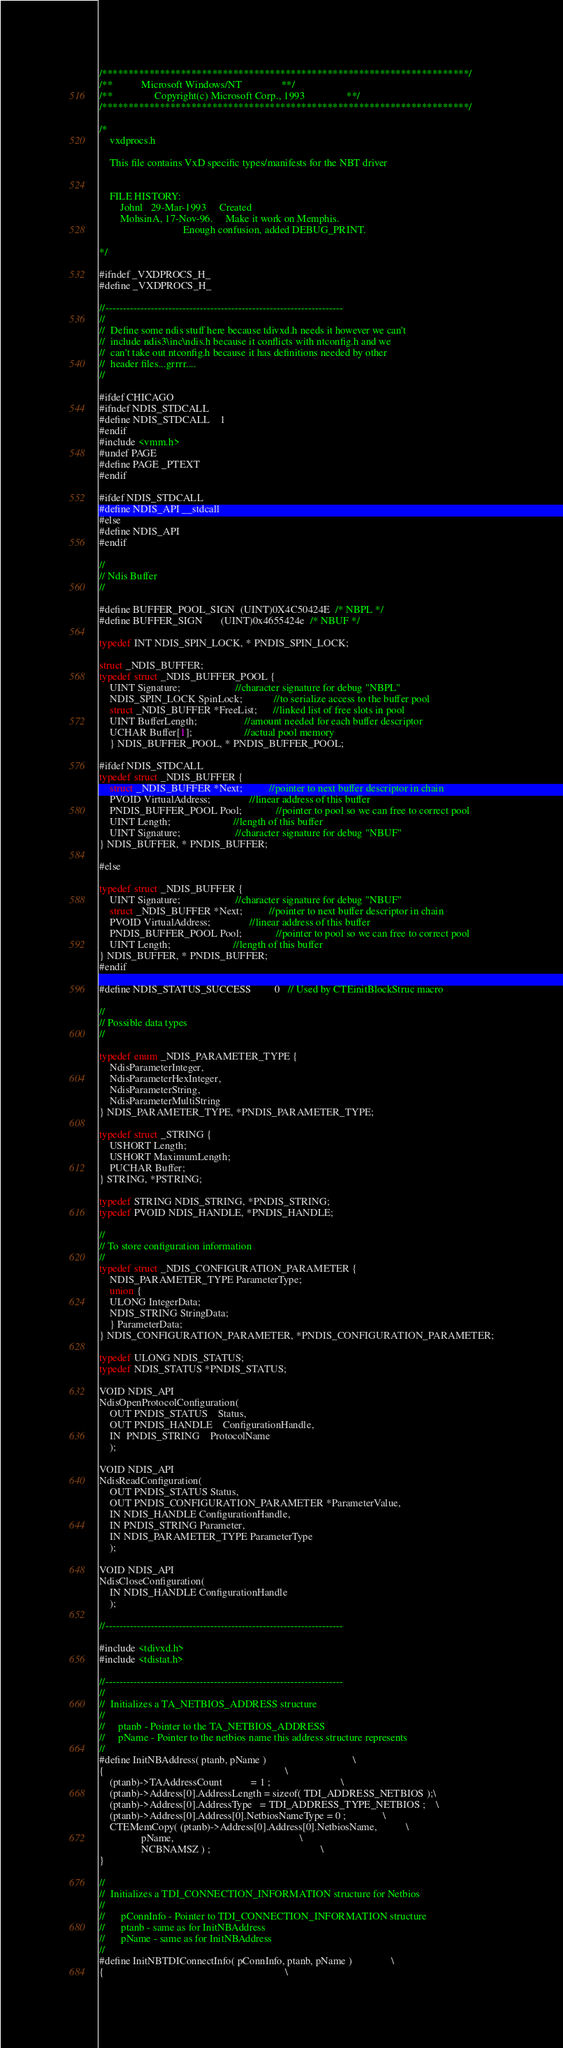<code> <loc_0><loc_0><loc_500><loc_500><_C_>/**********************************************************************/
/**           Microsoft Windows/NT               **/
/**                Copyright(c) Microsoft Corp., 1993                **/
/**********************************************************************/

/*
    vxdprocs.h

    This file contains VxD specific types/manifests for the NBT driver


    FILE HISTORY:
        Johnl   29-Mar-1993     Created
        MohsinA, 17-Nov-96.     Make it work on Memphis.
                                Enough confusion, added DEBUG_PRINT.

*/

#ifndef _VXDPROCS_H_
#define _VXDPROCS_H_

//--------------------------------------------------------------------
//
//  Define some ndis stuff here because tdivxd.h needs it however we can't
//  include ndis3\inc\ndis.h because it conflicts with ntconfig.h and we
//  can't take out ntconfig.h because it has definitions needed by other
//  header files...grrrr....
//

#ifdef CHICAGO
#ifndef NDIS_STDCALL
#define NDIS_STDCALL    1
#endif
#include <vmm.h>
#undef PAGE
#define PAGE _PTEXT
#endif

#ifdef NDIS_STDCALL
#define NDIS_API __stdcall
#else
#define NDIS_API
#endif

//
// Ndis Buffer
//

#define BUFFER_POOL_SIGN  (UINT)0X4C50424E  /* NBPL */
#define BUFFER_SIGN       (UINT)0x4655424e  /* NBUF */

typedef INT NDIS_SPIN_LOCK, * PNDIS_SPIN_LOCK;

struct _NDIS_BUFFER;
typedef struct _NDIS_BUFFER_POOL {
    UINT Signature;                     //character signature for debug "NBPL"
    NDIS_SPIN_LOCK SpinLock;            //to serialize access to the buffer pool
    struct _NDIS_BUFFER *FreeList;      //linked list of free slots in pool
    UINT BufferLength;                  //amount needed for each buffer descriptor
    UCHAR Buffer[1];                    //actual pool memory
    } NDIS_BUFFER_POOL, * PNDIS_BUFFER_POOL;

#ifdef NDIS_STDCALL
typedef struct _NDIS_BUFFER {
    struct _NDIS_BUFFER *Next;          //pointer to next buffer descriptor in chain
    PVOID VirtualAddress;               //linear address of this buffer
    PNDIS_BUFFER_POOL Pool;             //pointer to pool so we can free to correct pool
    UINT Length;                        //length of this buffer
    UINT Signature;                     //character signature for debug "NBUF"
} NDIS_BUFFER, * PNDIS_BUFFER;

#else

typedef struct _NDIS_BUFFER {
    UINT Signature;                     //character signature for debug "NBUF"
    struct _NDIS_BUFFER *Next;          //pointer to next buffer descriptor in chain
    PVOID VirtualAddress;               //linear address of this buffer
    PNDIS_BUFFER_POOL Pool;             //pointer to pool so we can free to correct pool
    UINT Length;                        //length of this buffer
} NDIS_BUFFER, * PNDIS_BUFFER;
#endif

#define NDIS_STATUS_SUCCESS         0   // Used by CTEinitBlockStruc macro

//
// Possible data types
//

typedef enum _NDIS_PARAMETER_TYPE {
    NdisParameterInteger,
    NdisParameterHexInteger,
    NdisParameterString,
    NdisParameterMultiString
} NDIS_PARAMETER_TYPE, *PNDIS_PARAMETER_TYPE;

typedef struct _STRING {
    USHORT Length;
    USHORT MaximumLength;
    PUCHAR Buffer;
} STRING, *PSTRING;

typedef STRING NDIS_STRING, *PNDIS_STRING;
typedef PVOID NDIS_HANDLE, *PNDIS_HANDLE;

//
// To store configuration information
//
typedef struct _NDIS_CONFIGURATION_PARAMETER {
    NDIS_PARAMETER_TYPE ParameterType;
    union {
    ULONG IntegerData;
    NDIS_STRING StringData;
    } ParameterData;
} NDIS_CONFIGURATION_PARAMETER, *PNDIS_CONFIGURATION_PARAMETER;

typedef ULONG NDIS_STATUS;
typedef NDIS_STATUS *PNDIS_STATUS;

VOID NDIS_API
NdisOpenProtocolConfiguration(
    OUT PNDIS_STATUS    Status,
    OUT PNDIS_HANDLE    ConfigurationHandle,
    IN  PNDIS_STRING    ProtocolName
    );

VOID NDIS_API
NdisReadConfiguration(
    OUT PNDIS_STATUS Status,
    OUT PNDIS_CONFIGURATION_PARAMETER *ParameterValue,
    IN NDIS_HANDLE ConfigurationHandle,
    IN PNDIS_STRING Parameter,
    IN NDIS_PARAMETER_TYPE ParameterType
    );

VOID NDIS_API
NdisCloseConfiguration(
    IN NDIS_HANDLE ConfigurationHandle
    );

//--------------------------------------------------------------------

#include <tdivxd.h>
#include <tdistat.h>

//--------------------------------------------------------------------
//
//  Initializes a TA_NETBIOS_ADDRESS structure
//
//     ptanb - Pointer to the TA_NETBIOS_ADDRESS
//     pName - Pointer to the netbios name this address structure represents
//
#define InitNBAddress( ptanb, pName )                                 \
{                                                                     \
    (ptanb)->TAAddressCount           = 1 ;                           \
    (ptanb)->Address[0].AddressLength = sizeof( TDI_ADDRESS_NETBIOS );\
    (ptanb)->Address[0].AddressType   = TDI_ADDRESS_TYPE_NETBIOS ;    \
    (ptanb)->Address[0].Address[0].NetbiosNameType = 0 ;              \
    CTEMemCopy( (ptanb)->Address[0].Address[0].NetbiosName,           \
                pName,                                                \
                NCBNAMSZ ) ;                                          \
}

//
//  Initializes a TDI_CONNECTION_INFORMATION structure for Netbios
//
//      pConnInfo - Pointer to TDI_CONNECTION_INFORMATION structure
//      ptanb - same as for InitNBAddress
//      pName - same as for InitNBAddress
//
#define InitNBTDIConnectInfo( pConnInfo, ptanb, pName )               \
{                                                                     \</code> 